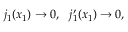Convert formula to latex. <formula><loc_0><loc_0><loc_500><loc_500>j _ { 1 } ( x _ { 1 } ) \rightarrow 0 , \ \ j _ { 1 } ^ { \prime } ( x _ { 1 } ) \rightarrow 0 ,</formula> 